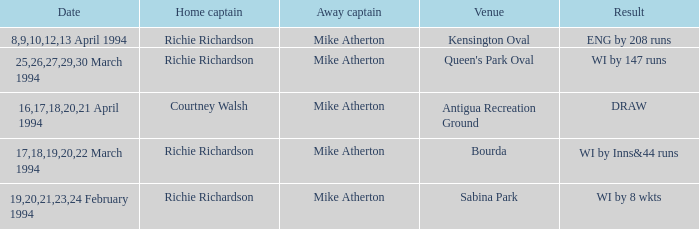Which Home captain has Date of 25,26,27,29,30 march 1994? Richie Richardson. 